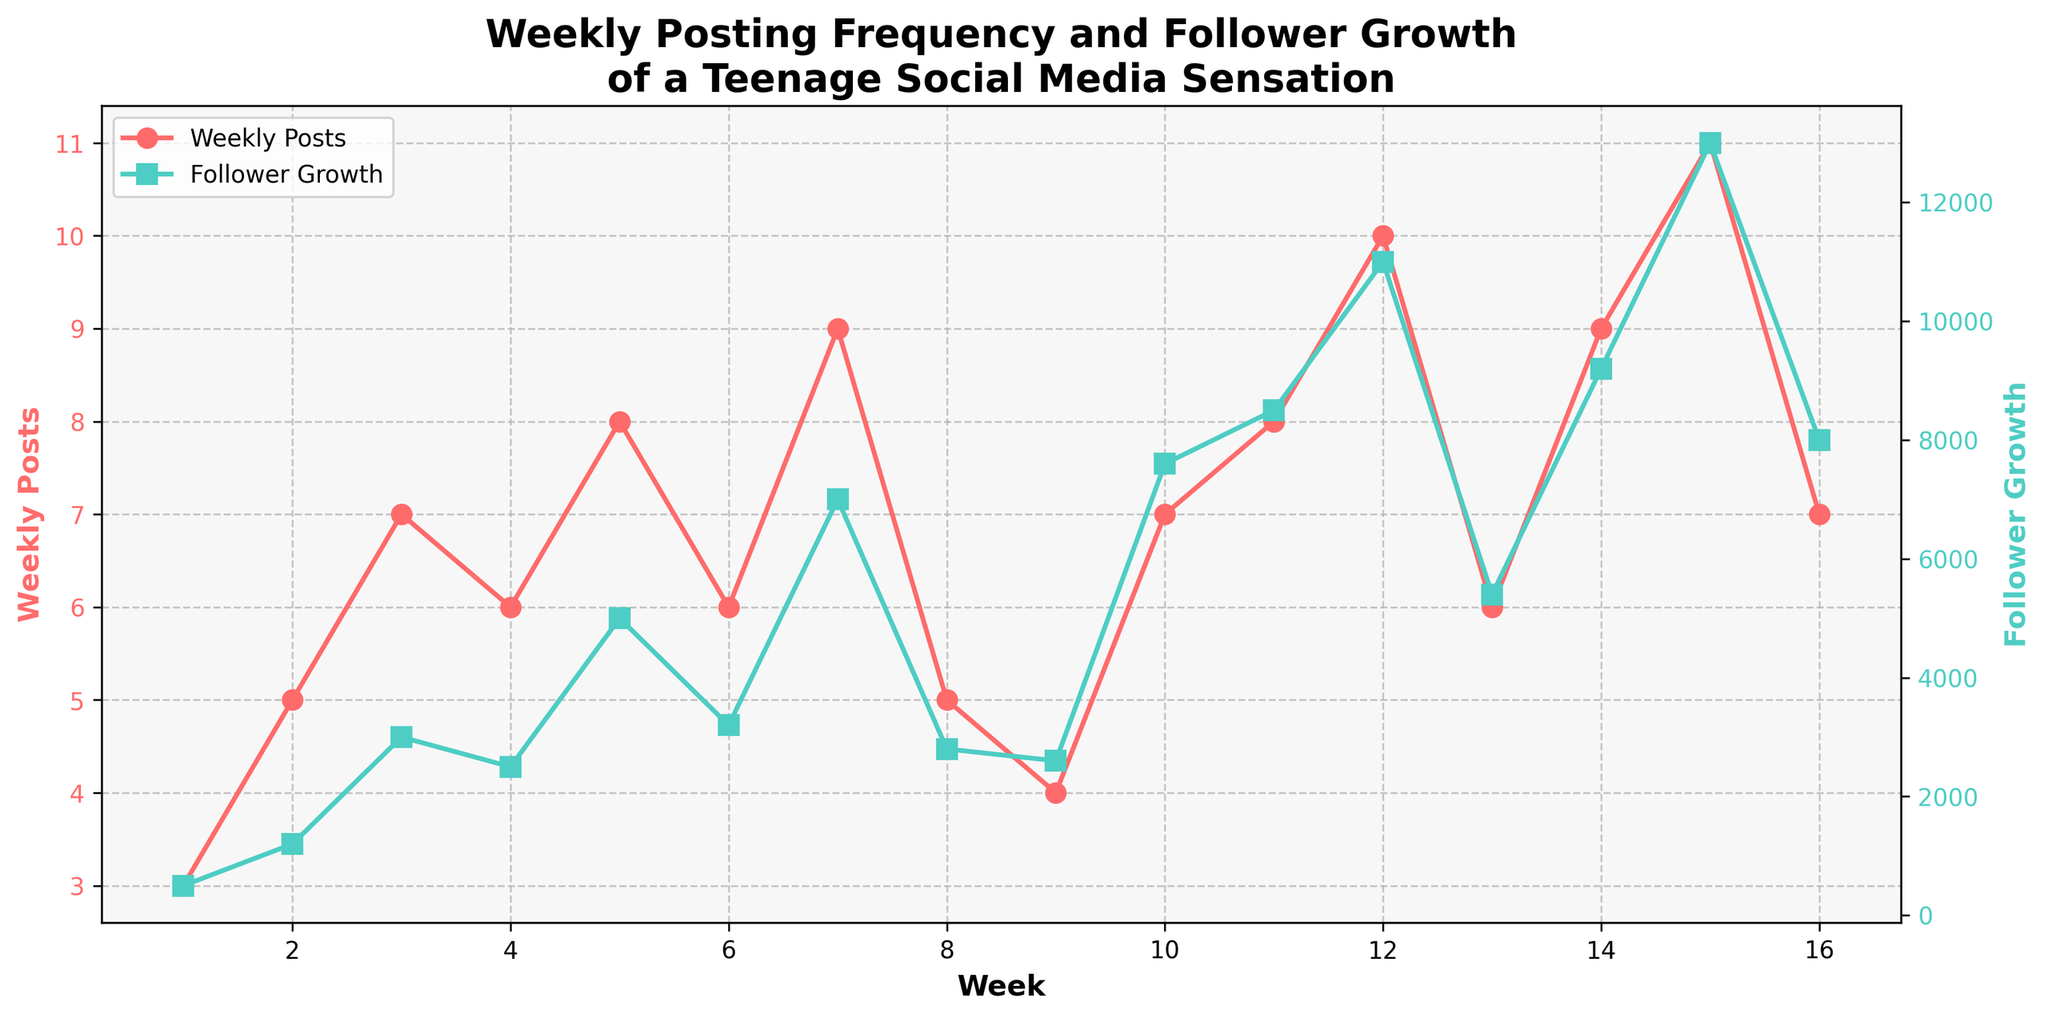In what week did the follower growth peak, and what was the value? Looking at the 'Follower Growth' line on the chart, the peak point corresponds to week 15. The 'Follower Growth' for week 15 is 13,000.
Answer: Week 15, 13,000 When did the weekly posts drop after reaching the highest level, and how many posts were there? The 'Weekly Posts' line shows its highest level at week 15 with 11 posts, and it drops in week 16 to 7 posts.
Answer: Week 16, 7 posts How does the number of weekly posts in week 10 compare to that in week 9? Week 9 has 4 posts whereas week 10 has 7 posts. So, the number of posts in week 10 is higher than in week 9 by 3 posts.
Answer: 3 more posts What's the average follower growth between weeks 1 and 8? Calculate the sum of the follower growth from weeks 1 to 8: 500 + 1200 + 3000 + 2500 + 5000 + 3200 + 7000 + 2800 = 25,200. Divide this sum by the number of weeks (8): 25,200 / 8 = 3,150.
Answer: 3,150 Was there a week with no change in the number of posts compared to the previous week? If yes, which week? The 'Weekly Posts' line has no point where the value remains constant from one week to the next. Every week shows a change in the number of posts compared to the previous week.
Answer: No Which week had the biggest jump in follower growth compared to the previous week and what was the difference? Comparing follower growth week by week, the biggest jump is between week 14 (9,200) and week 15 (13,000). The difference is 13,000 - 9,200 = 3,800.
Answer: Week 15, 3,800 How many weeks had follower growth above 8,000? Examine the 'Follower Growth' line on the chart: weeks 10, 11, 12, 14, and 15 show values above 8,000. Therefore, there are 5 such weeks.
Answer: 5 weeks What trend can be observed in the weekly posts from weeks 12 to 16? The 'Weekly Posts' line shows a decrease from week 12 (10 posts) to week 13 (6 posts), followed by an increase to 9 posts in week 14, then to 11 posts in week 15, and a decrease to 7 posts in week 16, indicating fluctuations.
Answer: Decrease, increase, then decrease 